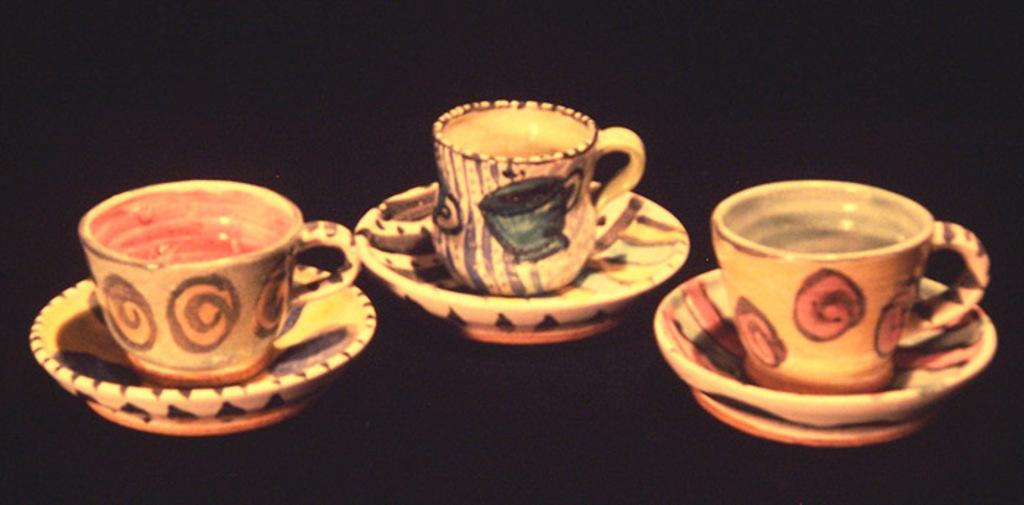What type of dishware can be seen in the image? There are cups and saucers in the image. Can you describe the background of the image? The background of the image is dark. What type of appliance is visible in the image? There is no appliance present in the image; it only features cups and saucers on a dark background. What country is the image taken from, and how does it relate to the border? The image does not provide any information about its origin or any borders, as it only shows cups and saucers on a dark background. 